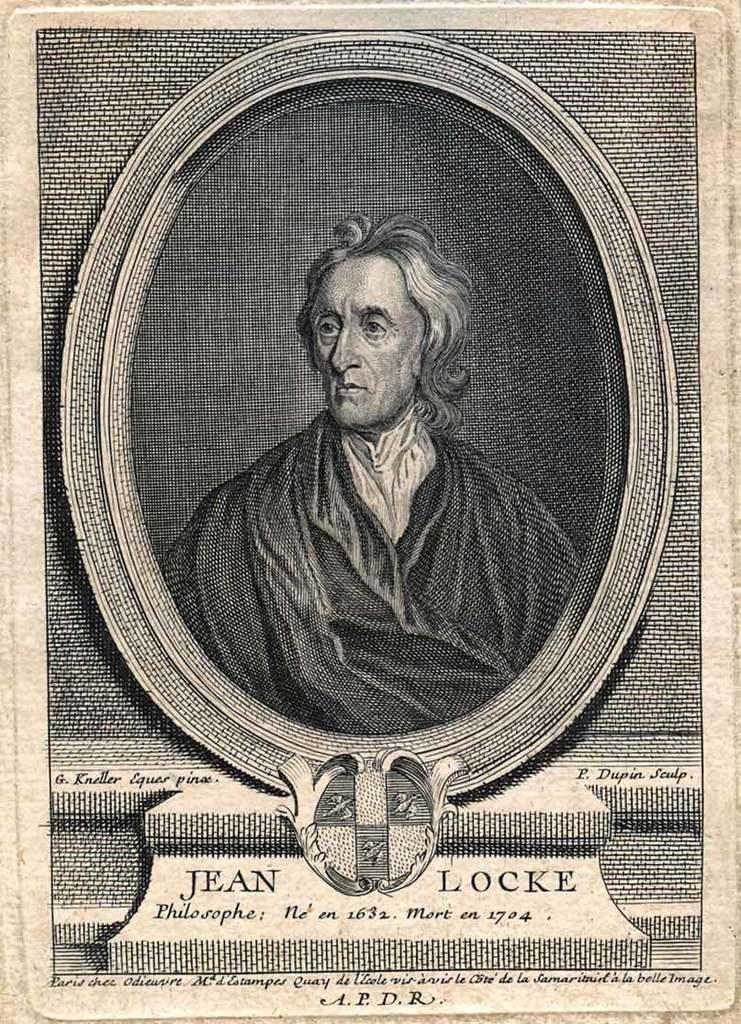<image>
Give a short and clear explanation of the subsequent image. An old picture of Jean Locke is in black and white. 